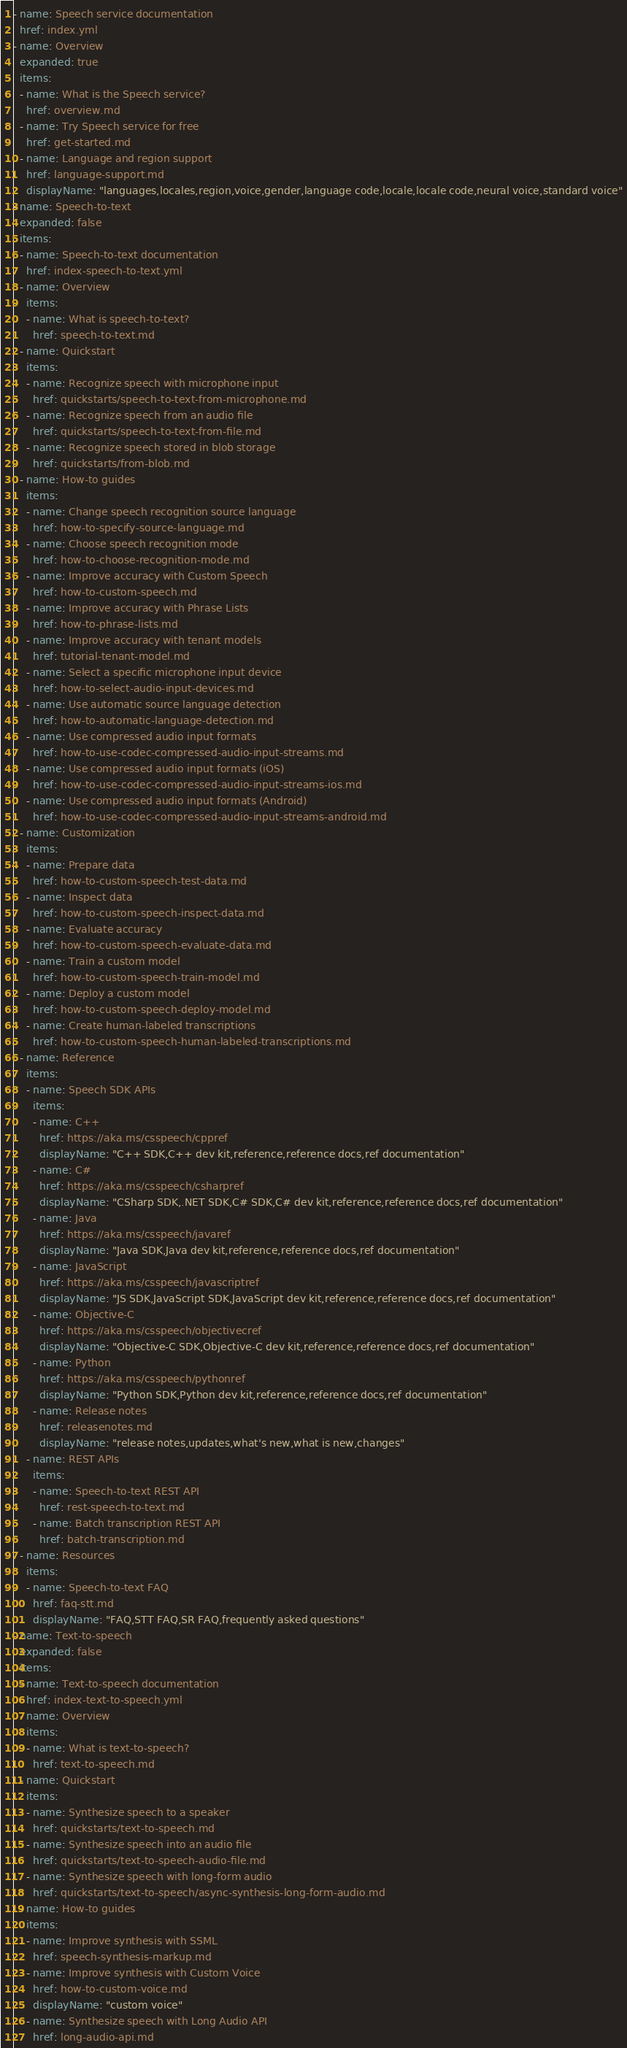Convert code to text. <code><loc_0><loc_0><loc_500><loc_500><_YAML_>- name: Speech service documentation
  href: index.yml
- name: Overview
  expanded: true
  items:
  - name: What is the Speech service?
    href: overview.md
  - name: Try Speech service for free
    href: get-started.md
  - name: Language and region support
    href: language-support.md
    displayName: "languages,locales,region,voice,gender,language code,locale,locale code,neural voice,standard voice"
- name: Speech-to-text
  expanded: false
  items:
  - name: Speech-to-text documentation
    href: index-speech-to-text.yml
  - name: Overview
    items:
    - name: What is speech-to-text?
      href: speech-to-text.md
  - name: Quickstart
    items:
    - name: Recognize speech with microphone input
      href: quickstarts/speech-to-text-from-microphone.md
    - name: Recognize speech from an audio file
      href: quickstarts/speech-to-text-from-file.md
    - name: Recognize speech stored in blob storage
      href: quickstarts/from-blob.md
  - name: How-to guides
    items:
    - name: Change speech recognition source language
      href: how-to-specify-source-language.md
    - name: Choose speech recognition mode
      href: how-to-choose-recognition-mode.md
    - name: Improve accuracy with Custom Speech
      href: how-to-custom-speech.md
    - name: Improve accuracy with Phrase Lists
      href: how-to-phrase-lists.md
    - name: Improve accuracy with tenant models
      href: tutorial-tenant-model.md
    - name: Select a specific microphone input device
      href: how-to-select-audio-input-devices.md
    - name: Use automatic source language detection
      href: how-to-automatic-language-detection.md
    - name: Use compressed audio input formats
      href: how-to-use-codec-compressed-audio-input-streams.md
    - name: Use compressed audio input formats (iOS)
      href: how-to-use-codec-compressed-audio-input-streams-ios.md
    - name: Use compressed audio input formats (Android)
      href: how-to-use-codec-compressed-audio-input-streams-android.md
  - name: Customization
    items:
    - name: Prepare data
      href: how-to-custom-speech-test-data.md
    - name: Inspect data
      href: how-to-custom-speech-inspect-data.md
    - name: Evaluate accuracy
      href: how-to-custom-speech-evaluate-data.md
    - name: Train a custom model
      href: how-to-custom-speech-train-model.md
    - name: Deploy a custom model
      href: how-to-custom-speech-deploy-model.md
    - name: Create human-labeled transcriptions
      href: how-to-custom-speech-human-labeled-transcriptions.md
  - name: Reference
    items:
    - name: Speech SDK APIs
      items:
      - name: C++
        href: https://aka.ms/csspeech/cppref
        displayName: "C++ SDK,C++ dev kit,reference,reference docs,ref documentation"
      - name: C#
        href: https://aka.ms/csspeech/csharpref
        displayName: "CSharp SDK,.NET SDK,C# SDK,C# dev kit,reference,reference docs,ref documentation"
      - name: Java
        href: https://aka.ms/csspeech/javaref
        displayName: "Java SDK,Java dev kit,reference,reference docs,ref documentation"
      - name: JavaScript
        href: https://aka.ms/csspeech/javascriptref
        displayName: "JS SDK,JavaScript SDK,JavaScript dev kit,reference,reference docs,ref documentation"
      - name: Objective-C
        href: https://aka.ms/csspeech/objectivecref
        displayName: "Objective-C SDK,Objective-C dev kit,reference,reference docs,ref documentation"
      - name: Python
        href: https://aka.ms/csspeech/pythonref
        displayName: "Python SDK,Python dev kit,reference,reference docs,ref documentation"
      - name: Release notes
        href: releasenotes.md
        displayName: "release notes,updates,what's new,what is new,changes"
    - name: REST APIs
      items:
      - name: Speech-to-text REST API
        href: rest-speech-to-text.md
      - name: Batch transcription REST API
        href: batch-transcription.md
  - name: Resources
    items:
    - name: Speech-to-text FAQ
      href: faq-stt.md
      displayName: "FAQ,STT FAQ,SR FAQ,frequently asked questions"
- name: Text-to-speech
  expanded: false
  items:
  - name: Text-to-speech documentation
    href: index-text-to-speech.yml
  - name: Overview
    items:
    - name: What is text-to-speech?
      href: text-to-speech.md
  - name: Quickstart
    items:
    - name: Synthesize speech to a speaker
      href: quickstarts/text-to-speech.md
    - name: Synthesize speech into an audio file
      href: quickstarts/text-to-speech-audio-file.md
    - name: Synthesize speech with long-form audio
      href: quickstarts/text-to-speech/async-synthesis-long-form-audio.md
  - name: How-to guides
    items:
    - name: Improve synthesis with SSML
      href: speech-synthesis-markup.md
    - name: Improve synthesis with Custom Voice
      href: how-to-custom-voice.md
      displayName: "custom voice"
    - name: Synthesize speech with Long Audio API
      href: long-audio-api.md</code> 